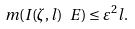Convert formula to latex. <formula><loc_0><loc_0><loc_500><loc_500>m ( I ( \zeta , l ) \ E ) \leq \varepsilon ^ { 2 } l .</formula> 